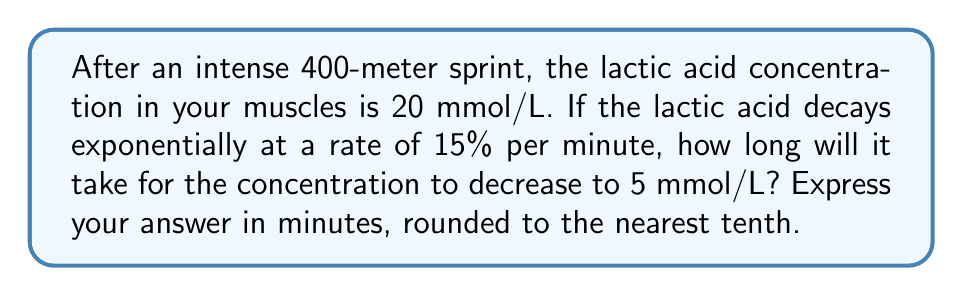Could you help me with this problem? Let's approach this step-by-step using the exponential decay formula:

1) The exponential decay formula is:
   $A(t) = A_0 \cdot (1-r)^t$

   Where:
   $A(t)$ is the amount at time $t$
   $A_0$ is the initial amount
   $r$ is the decay rate per unit time
   $t$ is the time

2) We know:
   $A_0 = 20$ mmol/L (initial concentration)
   $A(t) = 5$ mmol/L (final concentration)
   $r = 0.15$ (15% decay rate)

3) Let's plug these into our formula:
   $5 = 20 \cdot (1-0.15)^t$

4) Simplify:
   $5 = 20 \cdot (0.85)^t$

5) Divide both sides by 20:
   $\frac{1}{4} = (0.85)^t$

6) Take the natural log of both sides:
   $\ln(\frac{1}{4}) = \ln((0.85)^t)$

7) Use the logarithm property $\ln(a^b) = b\ln(a)$:
   $\ln(\frac{1}{4}) = t \cdot \ln(0.85)$

8) Solve for $t$:
   $t = \frac{\ln(\frac{1}{4})}{\ln(0.85)}$

9) Calculate:
   $t \approx 9.03$ minutes

10) Rounding to the nearest tenth:
    $t \approx 9.0$ minutes
Answer: 9.0 minutes 